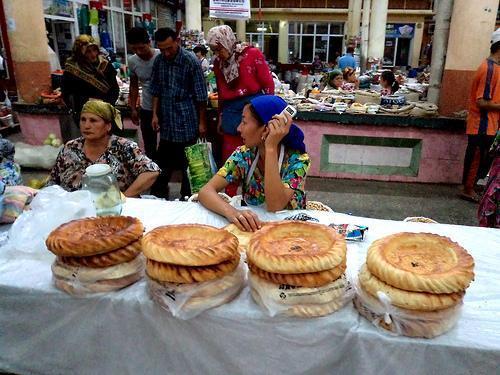How many people are buying cake?
Give a very brief answer. 0. 